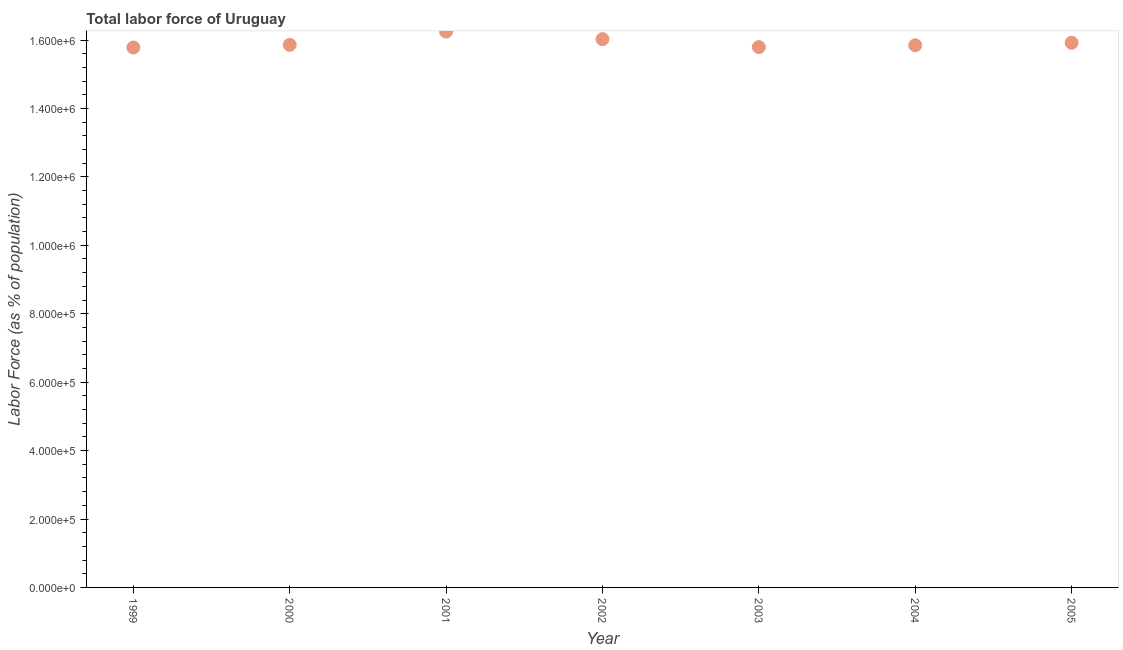What is the total labor force in 1999?
Keep it short and to the point. 1.58e+06. Across all years, what is the maximum total labor force?
Keep it short and to the point. 1.62e+06. Across all years, what is the minimum total labor force?
Provide a succinct answer. 1.58e+06. In which year was the total labor force maximum?
Offer a very short reply. 2001. What is the sum of the total labor force?
Your answer should be very brief. 1.11e+07. What is the difference between the total labor force in 2000 and 2003?
Offer a very short reply. 6679. What is the average total labor force per year?
Give a very brief answer. 1.59e+06. What is the median total labor force?
Ensure brevity in your answer.  1.59e+06. In how many years, is the total labor force greater than 1080000 %?
Ensure brevity in your answer.  7. What is the ratio of the total labor force in 2000 to that in 2005?
Your answer should be compact. 1. Is the difference between the total labor force in 2000 and 2005 greater than the difference between any two years?
Make the answer very short. No. What is the difference between the highest and the second highest total labor force?
Keep it short and to the point. 2.20e+04. Is the sum of the total labor force in 2001 and 2003 greater than the maximum total labor force across all years?
Ensure brevity in your answer.  Yes. What is the difference between the highest and the lowest total labor force?
Offer a very short reply. 4.65e+04. In how many years, is the total labor force greater than the average total labor force taken over all years?
Offer a terse response. 2. What is the difference between two consecutive major ticks on the Y-axis?
Ensure brevity in your answer.  2.00e+05. What is the title of the graph?
Give a very brief answer. Total labor force of Uruguay. What is the label or title of the Y-axis?
Offer a very short reply. Labor Force (as % of population). What is the Labor Force (as % of population) in 1999?
Keep it short and to the point. 1.58e+06. What is the Labor Force (as % of population) in 2000?
Offer a terse response. 1.59e+06. What is the Labor Force (as % of population) in 2001?
Ensure brevity in your answer.  1.62e+06. What is the Labor Force (as % of population) in 2002?
Keep it short and to the point. 1.60e+06. What is the Labor Force (as % of population) in 2003?
Provide a succinct answer. 1.58e+06. What is the Labor Force (as % of population) in 2004?
Keep it short and to the point. 1.58e+06. What is the Labor Force (as % of population) in 2005?
Keep it short and to the point. 1.59e+06. What is the difference between the Labor Force (as % of population) in 1999 and 2000?
Ensure brevity in your answer.  -7872. What is the difference between the Labor Force (as % of population) in 1999 and 2001?
Provide a succinct answer. -4.65e+04. What is the difference between the Labor Force (as % of population) in 1999 and 2002?
Ensure brevity in your answer.  -2.44e+04. What is the difference between the Labor Force (as % of population) in 1999 and 2003?
Make the answer very short. -1193. What is the difference between the Labor Force (as % of population) in 1999 and 2004?
Ensure brevity in your answer.  -6491. What is the difference between the Labor Force (as % of population) in 1999 and 2005?
Keep it short and to the point. -1.38e+04. What is the difference between the Labor Force (as % of population) in 2000 and 2001?
Your answer should be compact. -3.86e+04. What is the difference between the Labor Force (as % of population) in 2000 and 2002?
Your answer should be very brief. -1.66e+04. What is the difference between the Labor Force (as % of population) in 2000 and 2003?
Your response must be concise. 6679. What is the difference between the Labor Force (as % of population) in 2000 and 2004?
Your answer should be compact. 1381. What is the difference between the Labor Force (as % of population) in 2000 and 2005?
Offer a very short reply. -5920. What is the difference between the Labor Force (as % of population) in 2001 and 2002?
Your answer should be very brief. 2.20e+04. What is the difference between the Labor Force (as % of population) in 2001 and 2003?
Offer a very short reply. 4.53e+04. What is the difference between the Labor Force (as % of population) in 2001 and 2004?
Give a very brief answer. 4.00e+04. What is the difference between the Labor Force (as % of population) in 2001 and 2005?
Your response must be concise. 3.27e+04. What is the difference between the Labor Force (as % of population) in 2002 and 2003?
Keep it short and to the point. 2.33e+04. What is the difference between the Labor Force (as % of population) in 2002 and 2004?
Provide a succinct answer. 1.80e+04. What is the difference between the Labor Force (as % of population) in 2002 and 2005?
Your answer should be compact. 1.07e+04. What is the difference between the Labor Force (as % of population) in 2003 and 2004?
Keep it short and to the point. -5298. What is the difference between the Labor Force (as % of population) in 2003 and 2005?
Your answer should be very brief. -1.26e+04. What is the difference between the Labor Force (as % of population) in 2004 and 2005?
Provide a short and direct response. -7301. What is the ratio of the Labor Force (as % of population) in 1999 to that in 2001?
Keep it short and to the point. 0.97. What is the ratio of the Labor Force (as % of population) in 1999 to that in 2002?
Your answer should be very brief. 0.98. What is the ratio of the Labor Force (as % of population) in 1999 to that in 2004?
Offer a terse response. 1. What is the ratio of the Labor Force (as % of population) in 2000 to that in 2003?
Offer a very short reply. 1. What is the ratio of the Labor Force (as % of population) in 2000 to that in 2005?
Offer a very short reply. 1. What is the ratio of the Labor Force (as % of population) in 2001 to that in 2002?
Provide a succinct answer. 1.01. What is the ratio of the Labor Force (as % of population) in 2001 to that in 2003?
Provide a short and direct response. 1.03. What is the ratio of the Labor Force (as % of population) in 2002 to that in 2003?
Your answer should be very brief. 1.01. What is the ratio of the Labor Force (as % of population) in 2002 to that in 2004?
Give a very brief answer. 1.01. What is the ratio of the Labor Force (as % of population) in 2003 to that in 2004?
Provide a succinct answer. 1. What is the ratio of the Labor Force (as % of population) in 2003 to that in 2005?
Ensure brevity in your answer.  0.99. What is the ratio of the Labor Force (as % of population) in 2004 to that in 2005?
Provide a short and direct response. 0.99. 